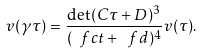<formula> <loc_0><loc_0><loc_500><loc_500>v ( \gamma \tau ) = \frac { \det ( C \tau + D ) ^ { 3 } } { ( \ f c t + \ f d ) ^ { 4 } } v ( \tau ) .</formula> 